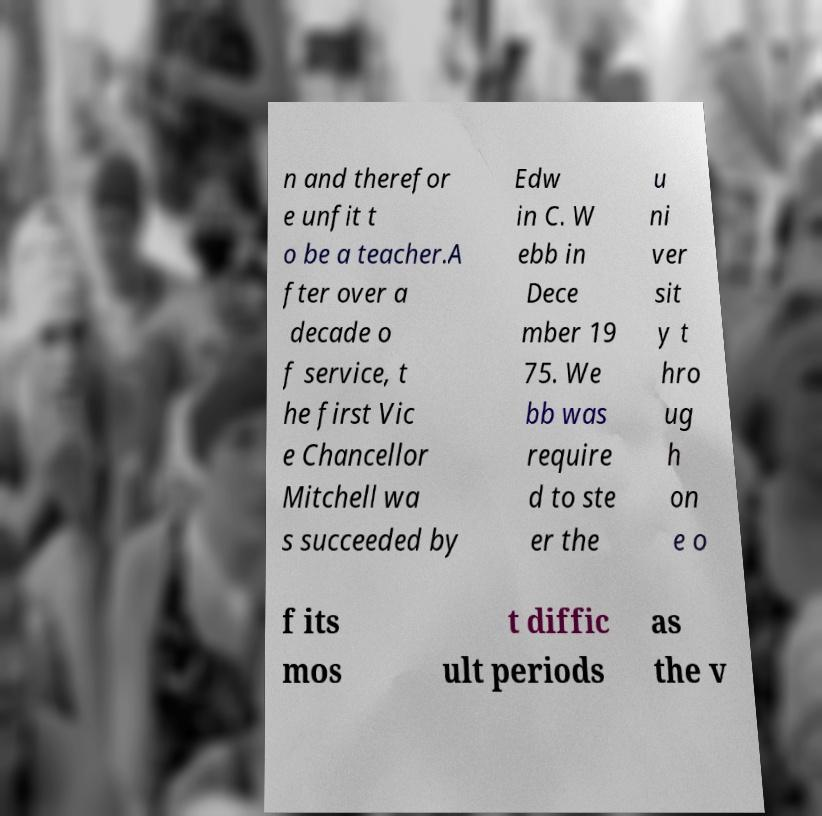Can you read and provide the text displayed in the image?This photo seems to have some interesting text. Can you extract and type it out for me? n and therefor e unfit t o be a teacher.A fter over a decade o f service, t he first Vic e Chancellor Mitchell wa s succeeded by Edw in C. W ebb in Dece mber 19 75. We bb was require d to ste er the u ni ver sit y t hro ug h on e o f its mos t diffic ult periods as the v 